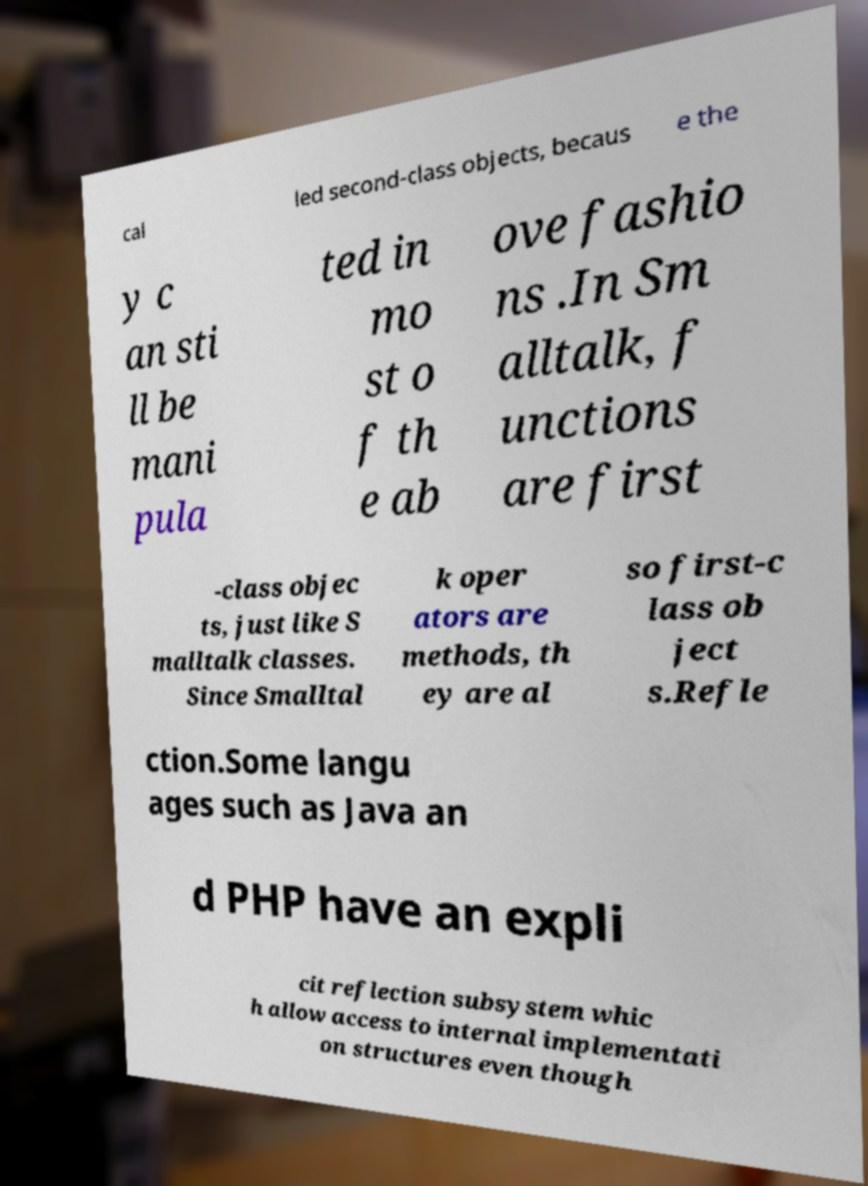Please identify and transcribe the text found in this image. cal led second-class objects, becaus e the y c an sti ll be mani pula ted in mo st o f th e ab ove fashio ns .In Sm alltalk, f unctions are first -class objec ts, just like S malltalk classes. Since Smalltal k oper ators are methods, th ey are al so first-c lass ob ject s.Refle ction.Some langu ages such as Java an d PHP have an expli cit reflection subsystem whic h allow access to internal implementati on structures even though 